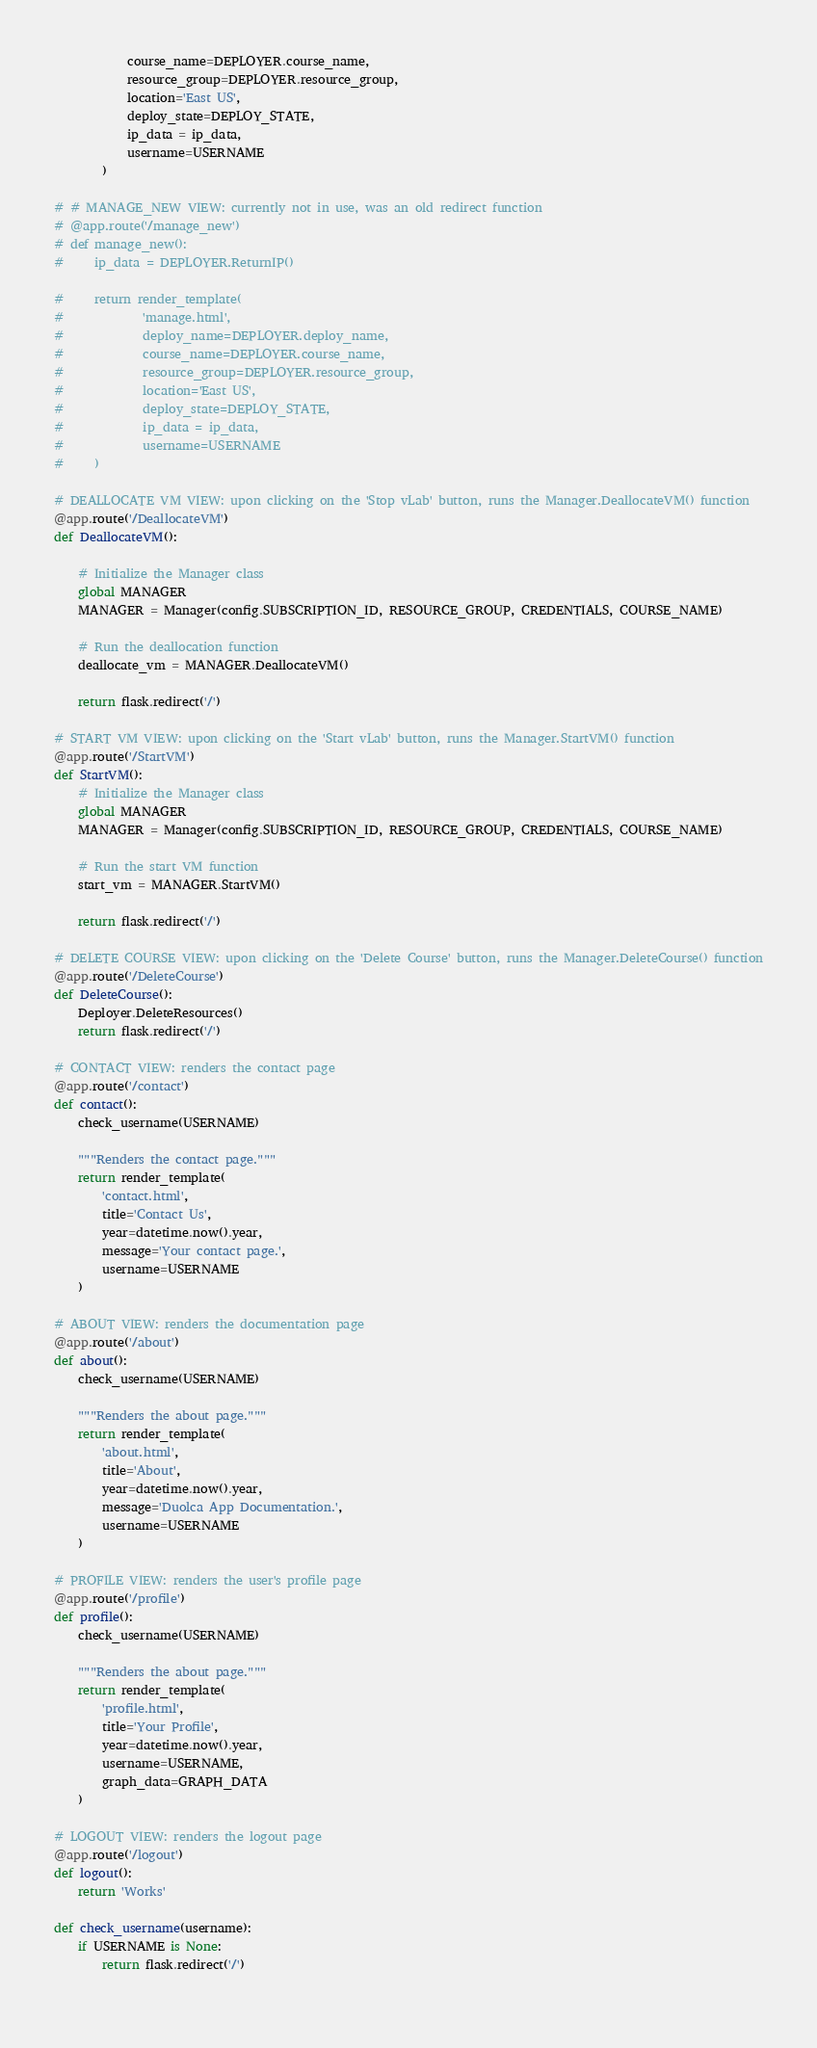<code> <loc_0><loc_0><loc_500><loc_500><_Python_>            course_name=DEPLOYER.course_name, 
            resource_group=DEPLOYER.resource_group,
            location='East US',
            deploy_state=DEPLOY_STATE, 
            ip_data = ip_data,
            username=USERNAME
        )

# # MANAGE_NEW VIEW: currently not in use, was an old redirect function
# @app.route('/manage_new')
# def manage_new():
#     ip_data = DEPLOYER.ReturnIP()

#     return render_template(
#             'manage.html', 
#             deploy_name=DEPLOYER.deploy_name,
#             course_name=DEPLOYER.course_name, 
#             resource_group=DEPLOYER.resource_group,
#             location='East US',
#             deploy_state=DEPLOY_STATE, 
#             ip_data = ip_data,
#             username=USERNAME
#     )

# DEALLOCATE VM VIEW: upon clicking on the 'Stop vLab' button, runs the Manager.DeallocateVM() function
@app.route('/DeallocateVM')
def DeallocateVM():

    # Initialize the Manager class 
    global MANAGER 
    MANAGER = Manager(config.SUBSCRIPTION_ID, RESOURCE_GROUP, CREDENTIALS, COURSE_NAME)

    # Run the deallocation function
    deallocate_vm = MANAGER.DeallocateVM()

    return flask.redirect('/')

# START VM VIEW: upon clicking on the 'Start vLab' button, runs the Manager.StartVM() function
@app.route('/StartVM')
def StartVM():
    # Initialize the Manager class 
    global MANAGER 
    MANAGER = Manager(config.SUBSCRIPTION_ID, RESOURCE_GROUP, CREDENTIALS, COURSE_NAME)

    # Run the start VM function 
    start_vm = MANAGER.StartVM()

    return flask.redirect('/')

# DELETE COURSE VIEW: upon clicking on the 'Delete Course' button, runs the Manager.DeleteCourse() function
@app.route('/DeleteCourse')
def DeleteCourse():
    Deployer.DeleteResources()
    return flask.redirect('/')

# CONTACT VIEW: renders the contact page
@app.route('/contact')
def contact():
    check_username(USERNAME)

    """Renders the contact page."""
    return render_template(
        'contact.html',
        title='Contact Us',
        year=datetime.now().year,
        message='Your contact page.',
        username=USERNAME
    )

# ABOUT VIEW: renders the documentation page 
@app.route('/about')
def about():
    check_username(USERNAME)

    """Renders the about page."""
    return render_template(
        'about.html',
        title='About',
        year=datetime.now().year,
        message='Duolca App Documentation.',
        username=USERNAME
    )

# PROFILE VIEW: renders the user's profile page 
@app.route('/profile')
def profile():
    check_username(USERNAME)

    """Renders the about page."""
    return render_template(
        'profile.html',
        title='Your Profile',
        year=datetime.now().year,
        username=USERNAME,
        graph_data=GRAPH_DATA
    )

# LOGOUT VIEW: renders the logout page 
@app.route('/logout')
def logout():
    return 'Works'

def check_username(username):
    if USERNAME is None:
        return flask.redirect('/')
    </code> 